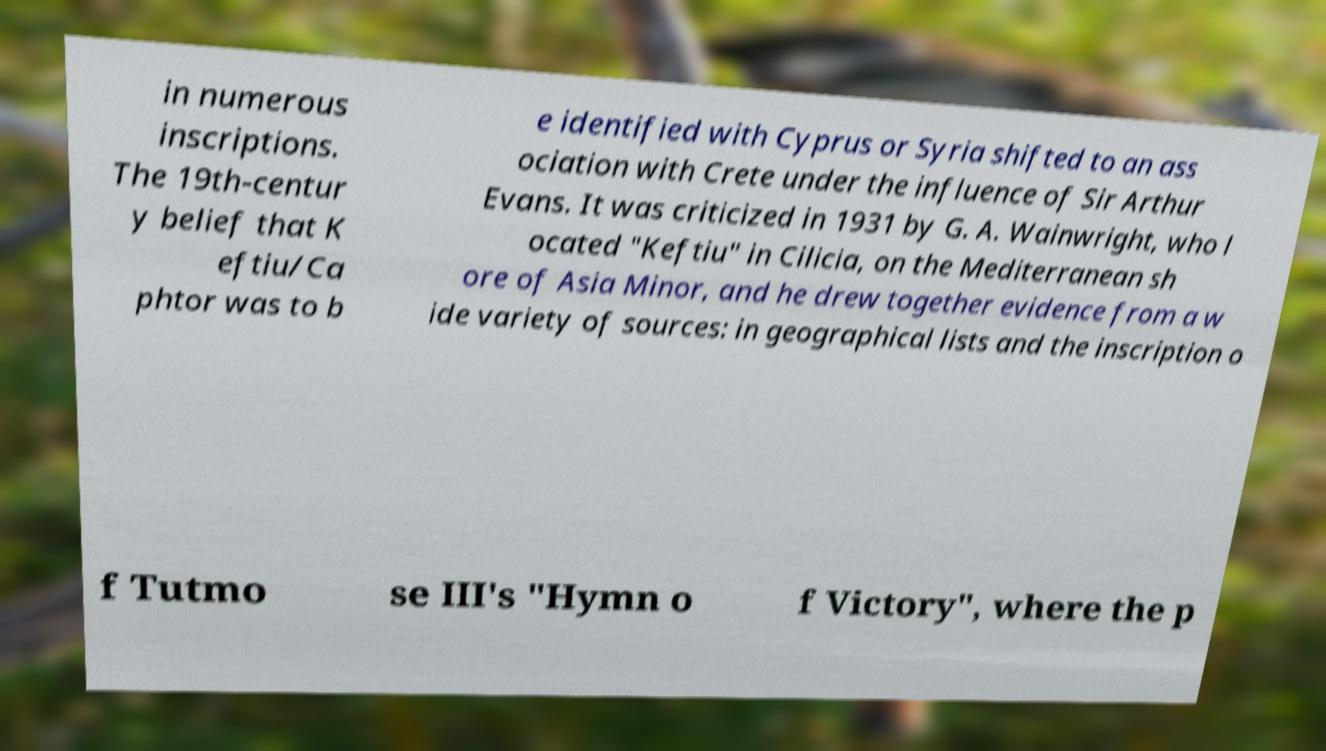Could you extract and type out the text from this image? in numerous inscriptions. The 19th-centur y belief that K eftiu/Ca phtor was to b e identified with Cyprus or Syria shifted to an ass ociation with Crete under the influence of Sir Arthur Evans. It was criticized in 1931 by G. A. Wainwright, who l ocated "Keftiu" in Cilicia, on the Mediterranean sh ore of Asia Minor, and he drew together evidence from a w ide variety of sources: in geographical lists and the inscription o f Tutmo se III's "Hymn o f Victory", where the p 